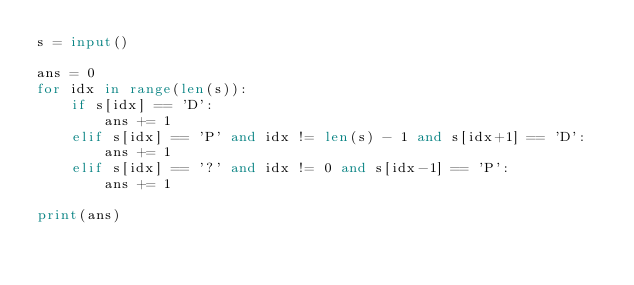<code> <loc_0><loc_0><loc_500><loc_500><_Python_>s = input()

ans = 0
for idx in range(len(s)):
    if s[idx] == 'D':
        ans += 1
    elif s[idx] == 'P' and idx != len(s) - 1 and s[idx+1] == 'D':
        ans += 1
    elif s[idx] == '?' and idx != 0 and s[idx-1] == 'P':
        ans += 1

print(ans)
</code> 